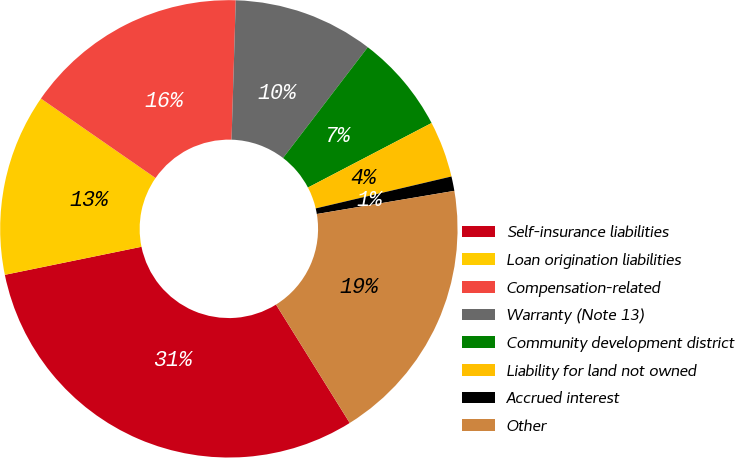Convert chart to OTSL. <chart><loc_0><loc_0><loc_500><loc_500><pie_chart><fcel>Self-insurance liabilities<fcel>Loan origination liabilities<fcel>Compensation-related<fcel>Warranty (Note 13)<fcel>Community development district<fcel>Liability for land not owned<fcel>Accrued interest<fcel>Other<nl><fcel>30.64%<fcel>12.87%<fcel>15.83%<fcel>9.91%<fcel>6.95%<fcel>3.98%<fcel>1.02%<fcel>18.79%<nl></chart> 